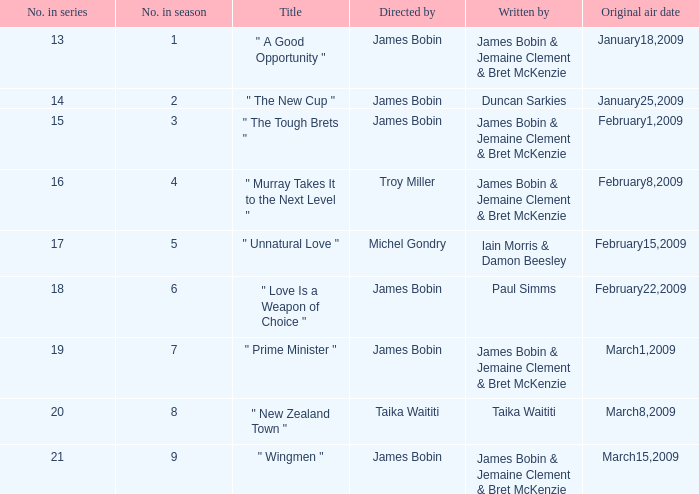Give me the full table as a dictionary. {'header': ['No. in series', 'No. in season', 'Title', 'Directed by', 'Written by', 'Original air date'], 'rows': [['13', '1', '" A Good Opportunity "', 'James Bobin', 'James Bobin & Jemaine Clement & Bret McKenzie', 'January18,2009'], ['14', '2', '" The New Cup "', 'James Bobin', 'Duncan Sarkies', 'January25,2009'], ['15', '3', '" The Tough Brets "', 'James Bobin', 'James Bobin & Jemaine Clement & Bret McKenzie', 'February1,2009'], ['16', '4', '" Murray Takes It to the Next Level "', 'Troy Miller', 'James Bobin & Jemaine Clement & Bret McKenzie', 'February8,2009'], ['17', '5', '" Unnatural Love "', 'Michel Gondry', 'Iain Morris & Damon Beesley', 'February15,2009'], ['18', '6', '" Love Is a Weapon of Choice "', 'James Bobin', 'Paul Simms', 'February22,2009'], ['19', '7', '" Prime Minister "', 'James Bobin', 'James Bobin & Jemaine Clement & Bret McKenzie', 'March1,2009'], ['20', '8', '" New Zealand Town "', 'Taika Waititi', 'Taika Waititi', 'March8,2009'], ['21', '9', '" Wingmen "', 'James Bobin', 'James Bobin & Jemaine Clement & Bret McKenzie', 'March15,2009']]}  what's the title where original air date is january18,2009 " A Good Opportunity ". 